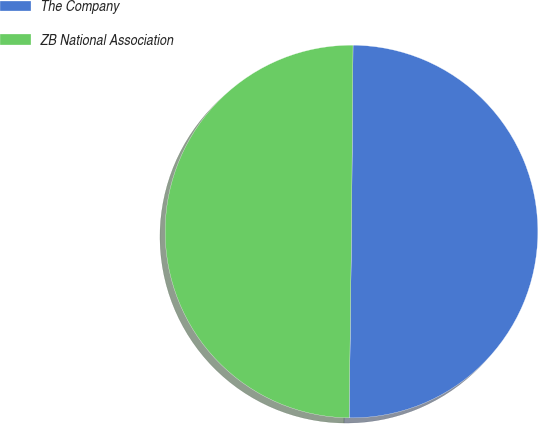<chart> <loc_0><loc_0><loc_500><loc_500><pie_chart><fcel>The Company<fcel>ZB National Association<nl><fcel>50.07%<fcel>49.93%<nl></chart> 